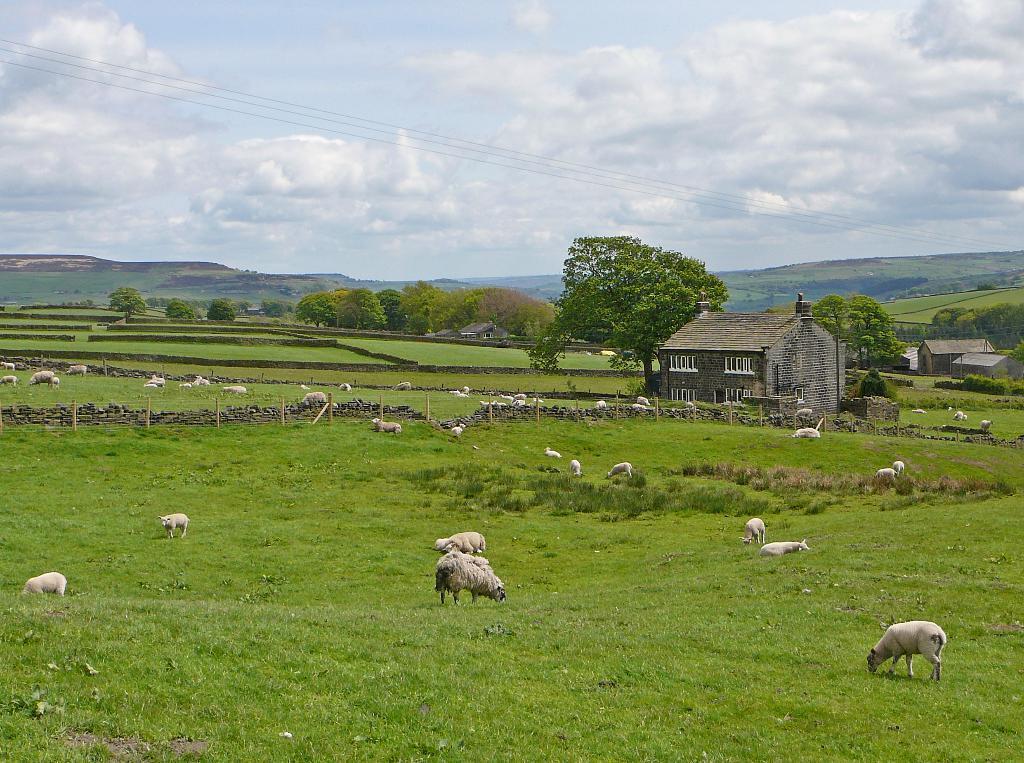Please provide a concise description of this image. In the picture we can see a grass surface on it, we can see some sheep are grazing the grass and behind it, we can see a house and beside it, we can see some tree and in the background also we can see some trees, hills and sky. 